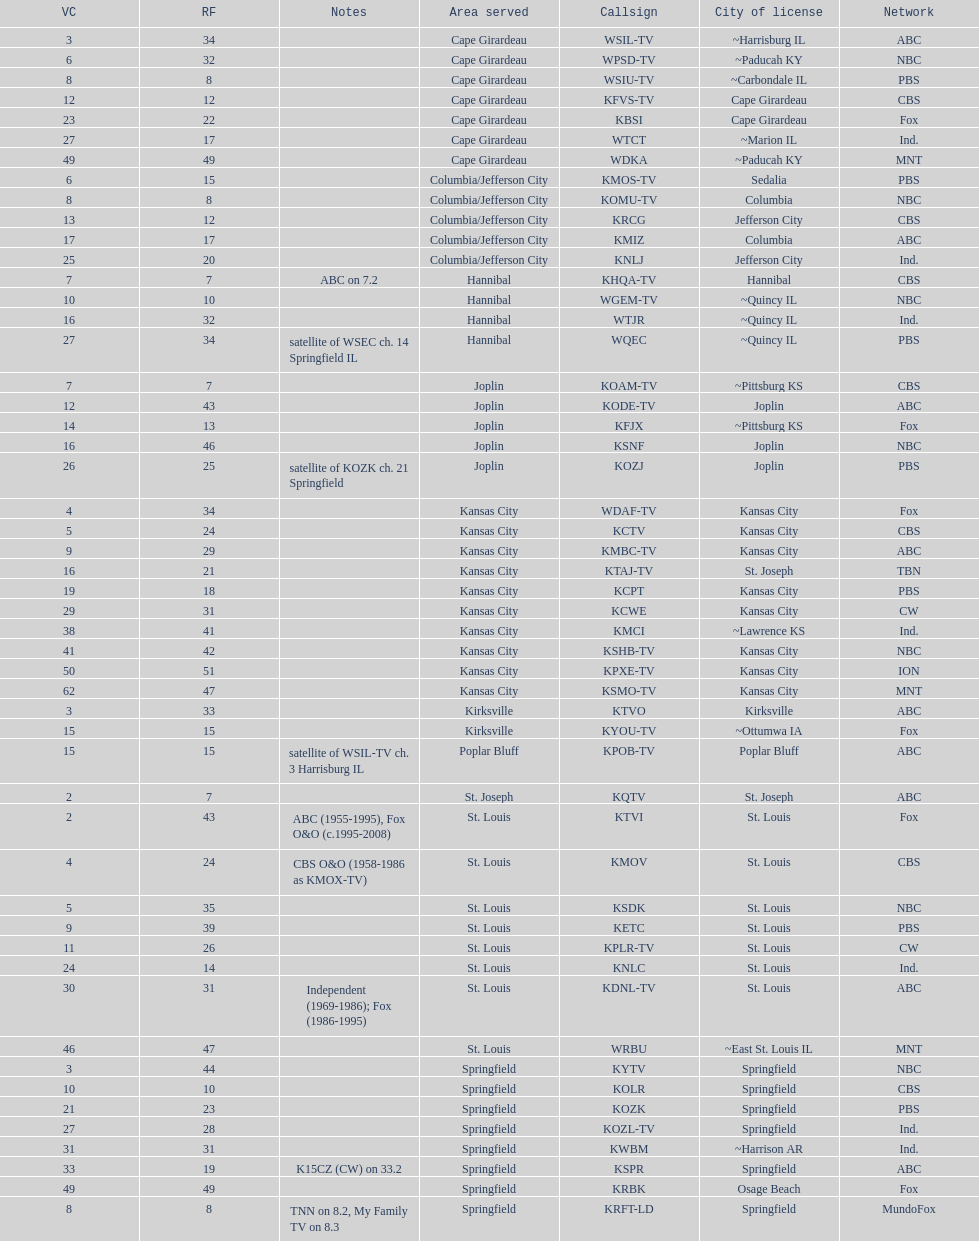How many of these missouri tv stations are actually licensed in a city in illinois (il)? 7. 